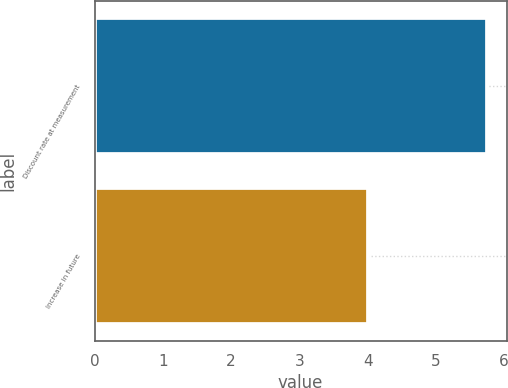<chart> <loc_0><loc_0><loc_500><loc_500><bar_chart><fcel>Discount rate at measurement<fcel>Increase in future<nl><fcel>5.75<fcel>4<nl></chart> 